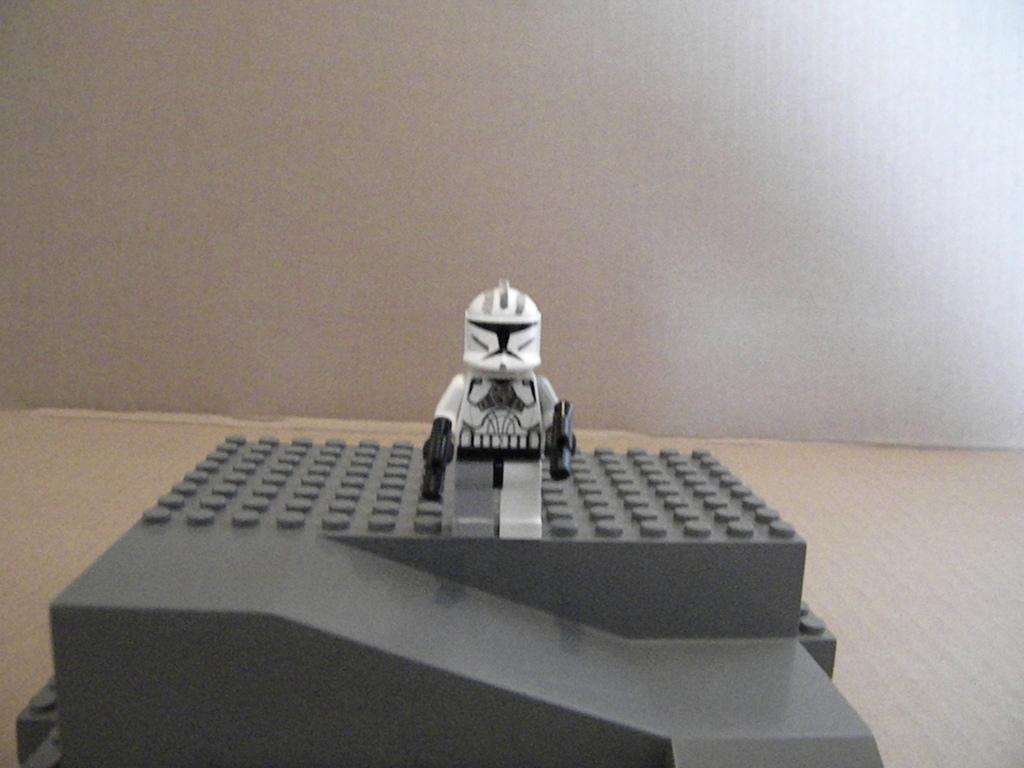What type of object is in the image? There is a gadget and a toy in the image. Can you describe the background of the image? There is a wall in the background of the image. What type of friction can be observed between the gadget and the toy in the image? There is no friction between the gadget and the toy in the image, as they are separate objects and not interacting with each other. 